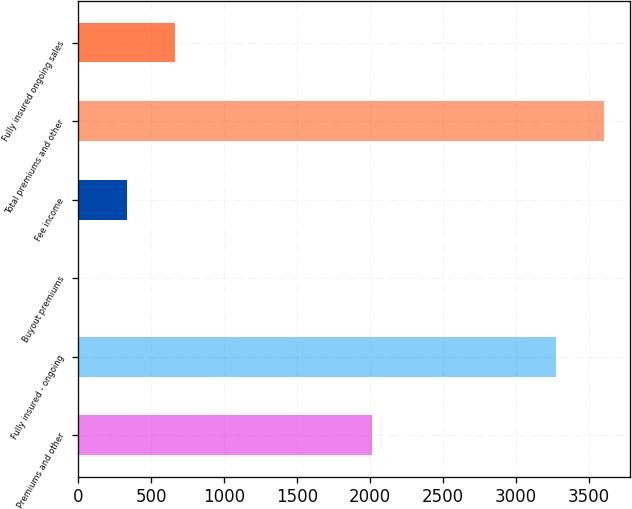Convert chart. <chart><loc_0><loc_0><loc_500><loc_500><bar_chart><fcel>Premiums and other<fcel>Fully insured - ongoing<fcel>Buyout premiums<fcel>Fee income<fcel>Total premiums and other<fcel>Fully insured ongoing sales<nl><fcel>2013<fcel>3272<fcel>1<fcel>333.9<fcel>3604.9<fcel>666.8<nl></chart> 